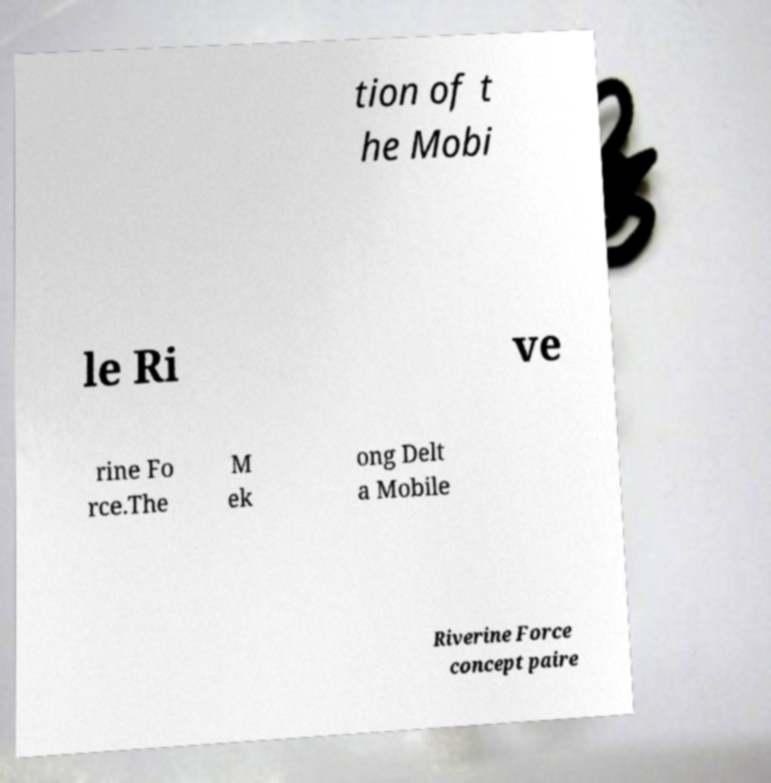Can you accurately transcribe the text from the provided image for me? tion of t he Mobi le Ri ve rine Fo rce.The M ek ong Delt a Mobile Riverine Force concept paire 